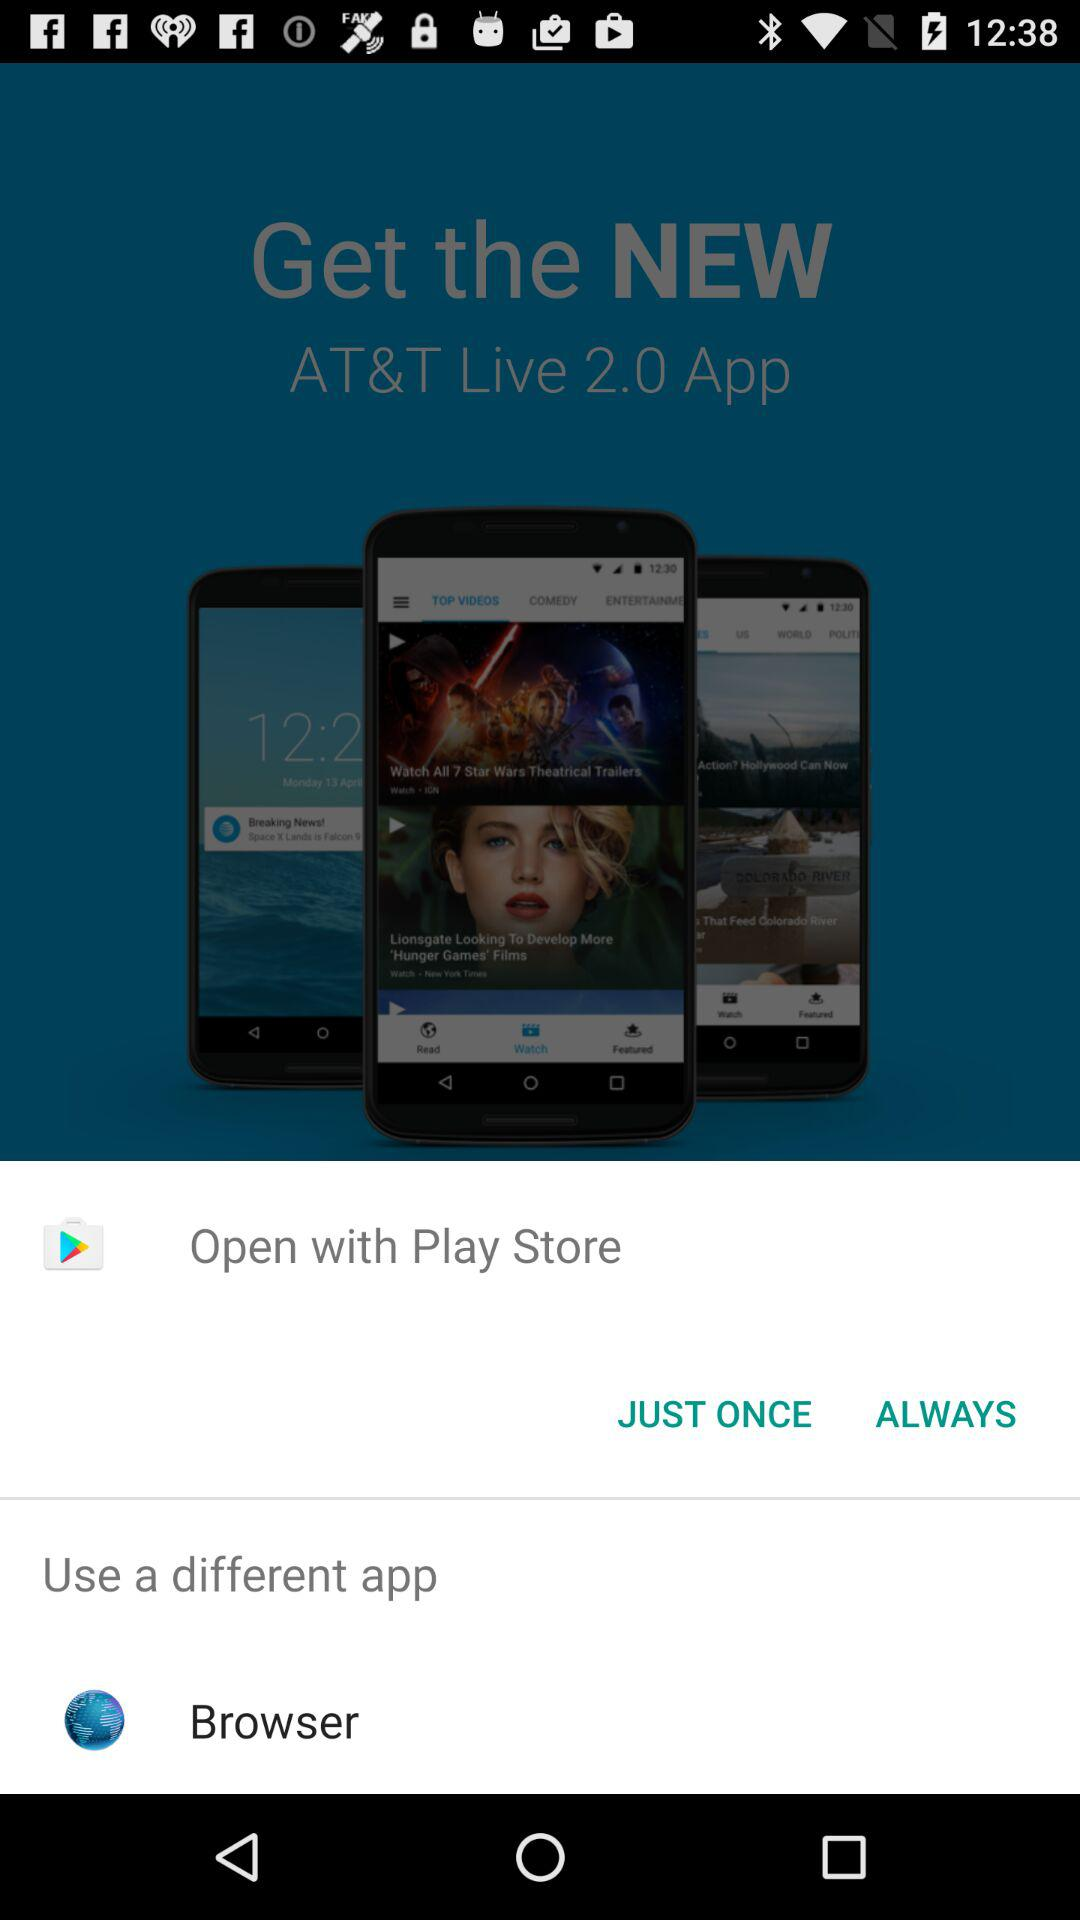What different app can I use to open it? The different app is "Browser". 